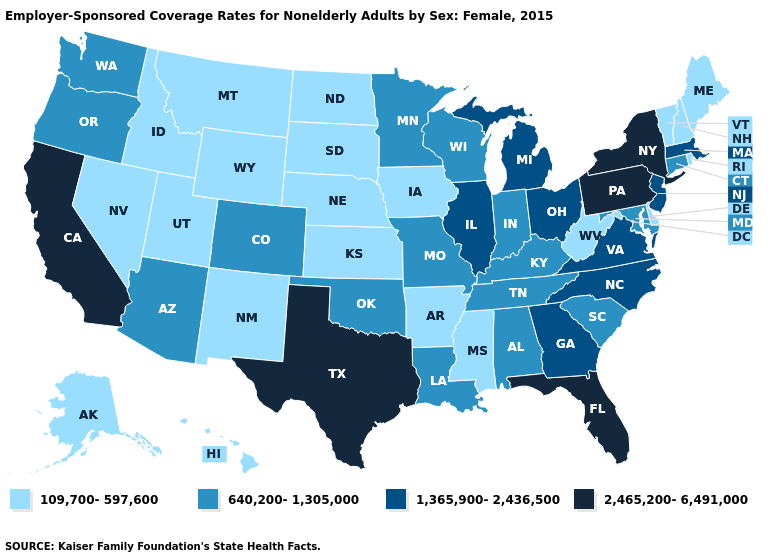Name the states that have a value in the range 1,365,900-2,436,500?
Quick response, please. Georgia, Illinois, Massachusetts, Michigan, New Jersey, North Carolina, Ohio, Virginia. Name the states that have a value in the range 2,465,200-6,491,000?
Give a very brief answer. California, Florida, New York, Pennsylvania, Texas. How many symbols are there in the legend?
Answer briefly. 4. Does the map have missing data?
Write a very short answer. No. Among the states that border Georgia , which have the lowest value?
Be succinct. Alabama, South Carolina, Tennessee. What is the lowest value in the USA?
Give a very brief answer. 109,700-597,600. Name the states that have a value in the range 1,365,900-2,436,500?
Give a very brief answer. Georgia, Illinois, Massachusetts, Michigan, New Jersey, North Carolina, Ohio, Virginia. Does the map have missing data?
Answer briefly. No. What is the value of Michigan?
Give a very brief answer. 1,365,900-2,436,500. Among the states that border Missouri , does Arkansas have the highest value?
Short answer required. No. What is the lowest value in states that border Wyoming?
Concise answer only. 109,700-597,600. What is the highest value in the USA?
Quick response, please. 2,465,200-6,491,000. What is the value of New Jersey?
Answer briefly. 1,365,900-2,436,500. Name the states that have a value in the range 2,465,200-6,491,000?
Answer briefly. California, Florida, New York, Pennsylvania, Texas. Among the states that border Delaware , does Pennsylvania have the highest value?
Give a very brief answer. Yes. 